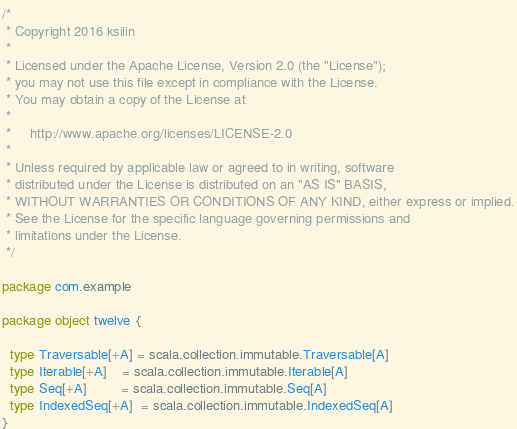<code> <loc_0><loc_0><loc_500><loc_500><_Scala_>/*
 * Copyright 2016 ksilin
 *
 * Licensed under the Apache License, Version 2.0 (the "License");
 * you may not use this file except in compliance with the License.
 * You may obtain a copy of the License at
 *
 *     http://www.apache.org/licenses/LICENSE-2.0
 *
 * Unless required by applicable law or agreed to in writing, software
 * distributed under the License is distributed on an "AS IS" BASIS,
 * WITHOUT WARRANTIES OR CONDITIONS OF ANY KIND, either express or implied.
 * See the License for the specific language governing permissions and
 * limitations under the License.
 */

package com.example

package object twelve {

  type Traversable[+A] = scala.collection.immutable.Traversable[A]
  type Iterable[+A]    = scala.collection.immutable.Iterable[A]
  type Seq[+A]         = scala.collection.immutable.Seq[A]
  type IndexedSeq[+A]  = scala.collection.immutable.IndexedSeq[A]
}
</code> 